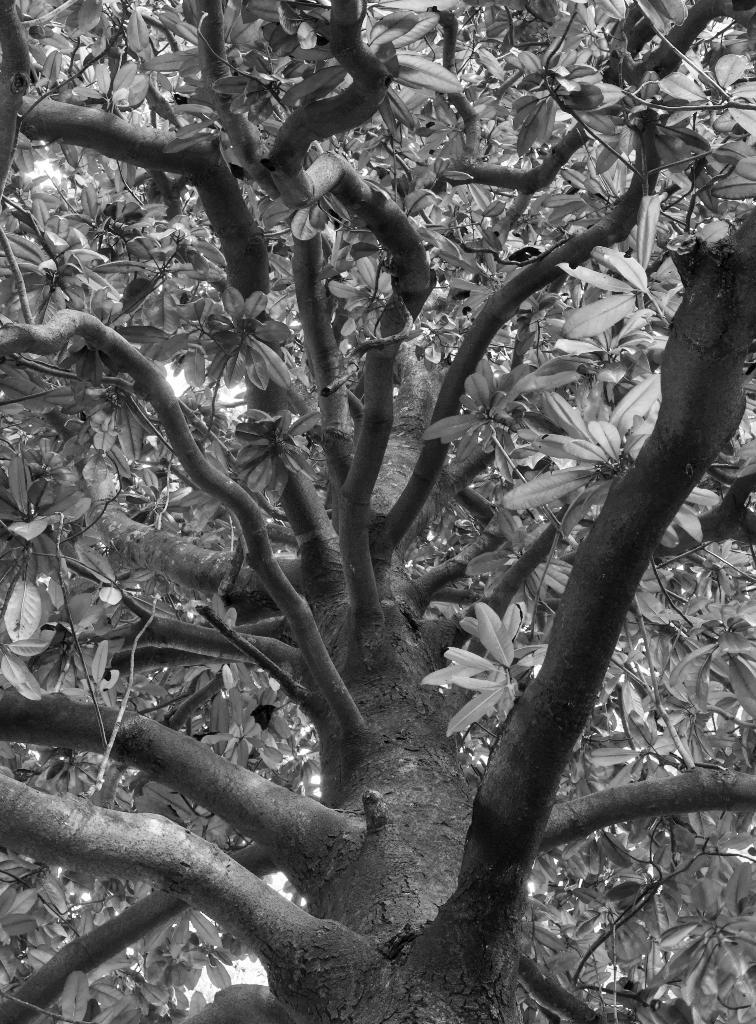What is the main subject of the image? The main subject of the image is a tree. Can you describe the tree in more detail? The image is a zoomed-in picture of a tree, and there are leaves visible in the middle of the image. What invention can be seen in the stomach of the tree in the image? There is no invention or stomach present in the image, as it is a picture of a tree with leaves. 